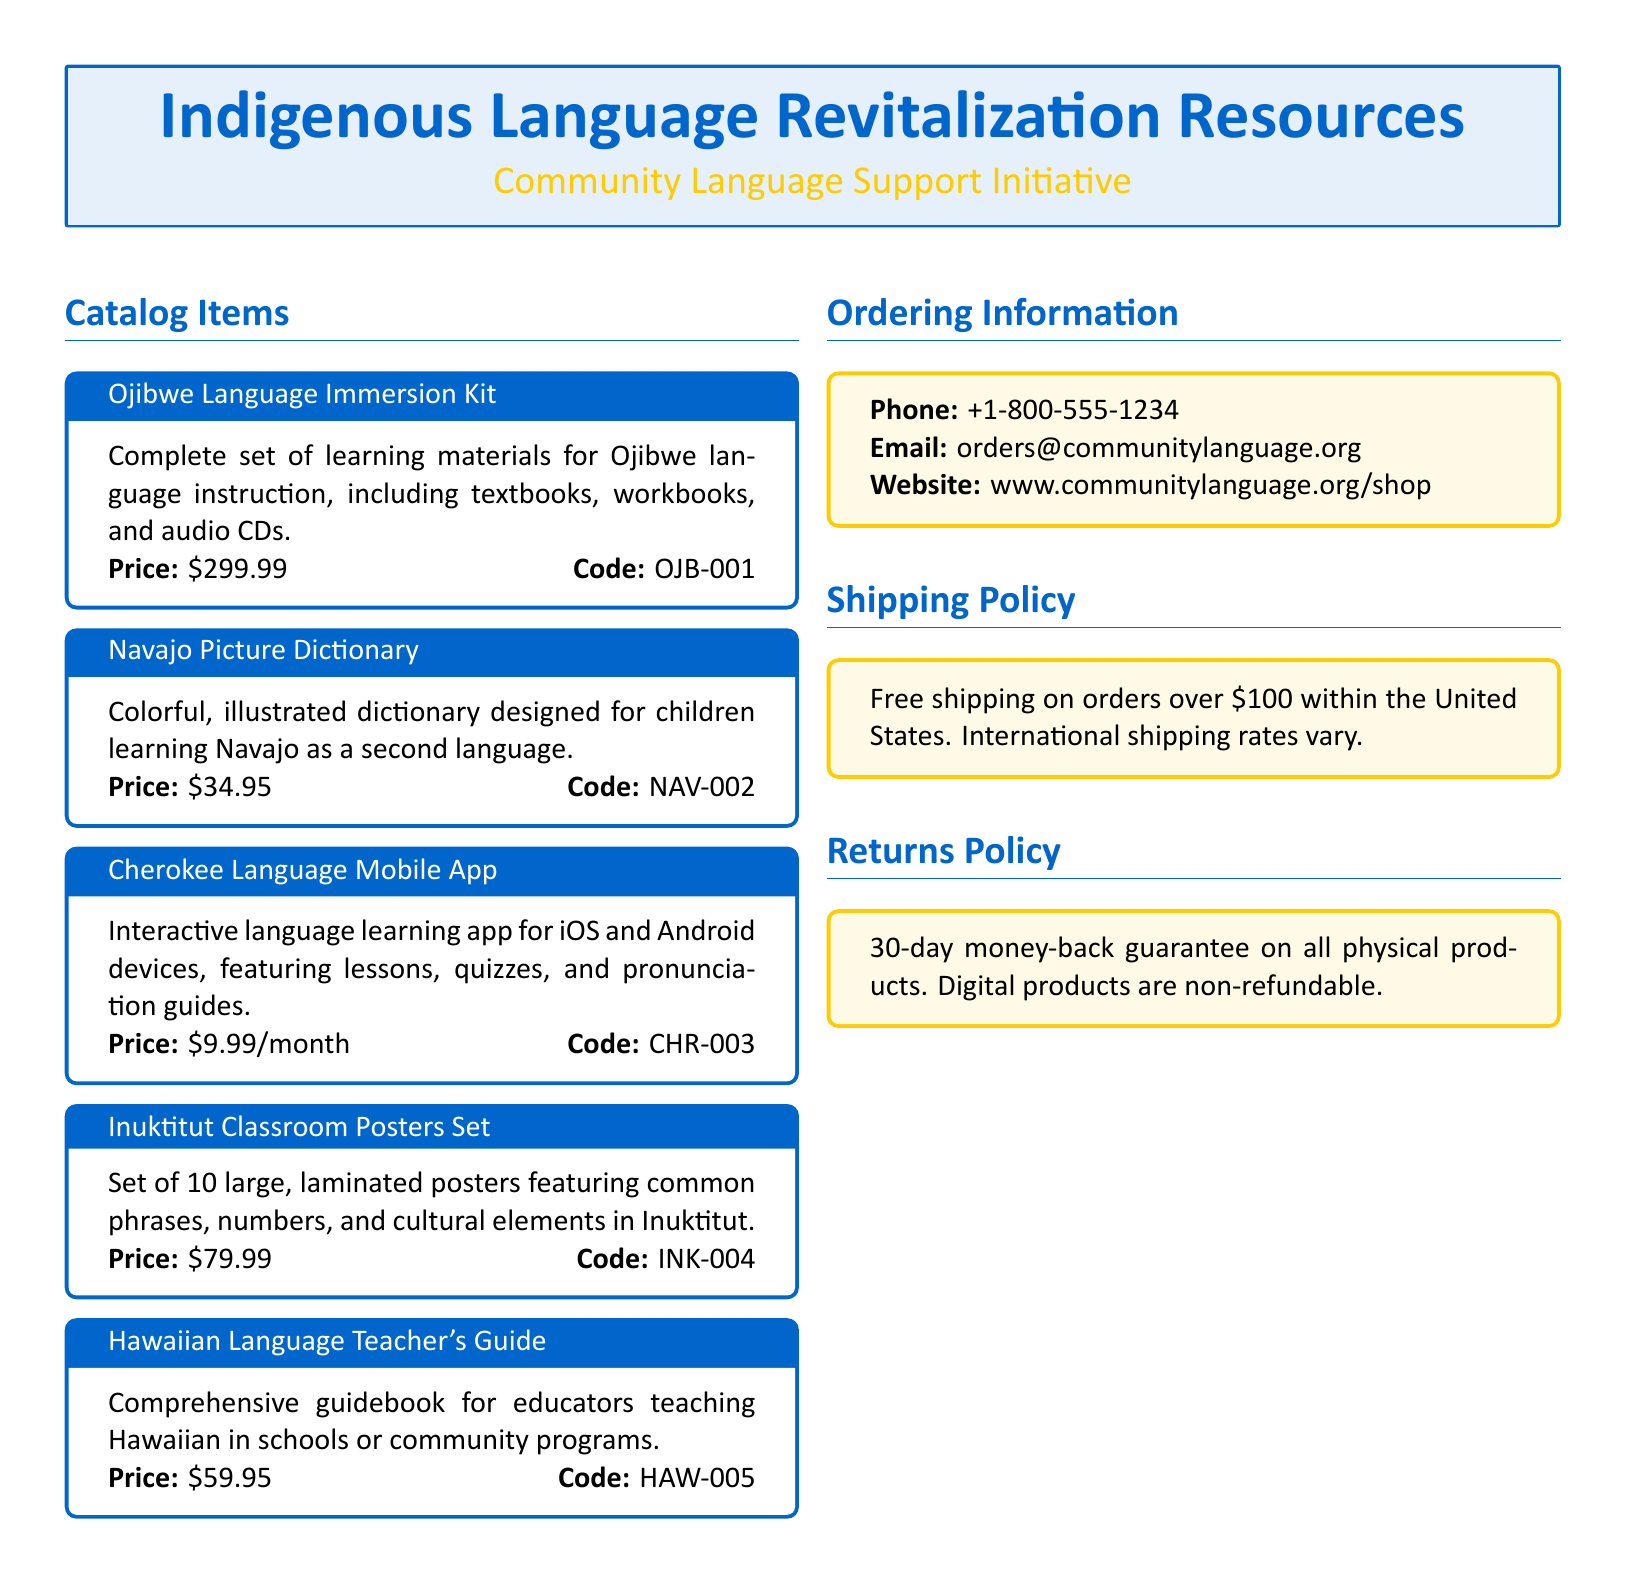What is the price of the Ojibwe Language Immersion Kit? The price listed for the Ojibwe Language Immersion Kit in the document is $299.99.
Answer: $299.99 What is the code for the Navajo Picture Dictionary? The document provides the code for the Navajo Picture Dictionary as NAV-002.
Answer: NAV-002 How many classroom posters are included in the Inuktitut Classroom Posters Set? The document states that the Inuktitut Classroom Posters Set includes a set of 10 posters.
Answer: 10 What is the shipping policy for orders over a certain amount? The shipping policy indicates free shipping on orders over $100 within the United States.
Answer: over $100 Which educational material is available for a monthly subscription? The document mentions the Cherokee Language Mobile App, which is available for $9.99 per month.
Answer: Cherokee Language Mobile App What is the return policy for physical products? According to the document, there is a 30-day money-back guarantee on all physical products.
Answer: 30-day money-back guarantee What type of product is the Hawaiian Language Teacher's Guide? The document categorizes the Hawaiian Language Teacher's Guide as a comprehensive guidebook for educators.
Answer: guidebook How can orders be placed through email? The document provides an email address for orders: orders@communitylanguage.org.
Answer: orders@communitylanguage.org What is the focus of the illustrated catalog? The catalog focuses on showcasing indigenous language learning materials and resources.
Answer: indigenous language learning materials 